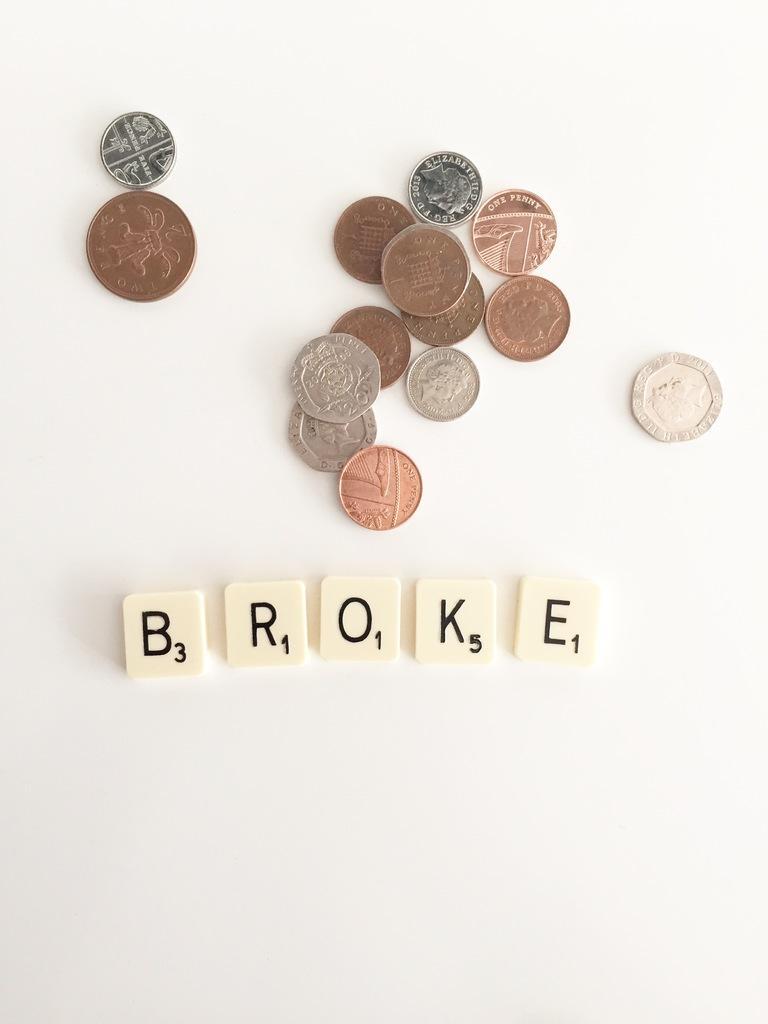In one or two sentences, can you explain what this image depicts? In the middle of this image, there are white, silver, copper and brown color coins arranged on a surface. And the background is white in color. 